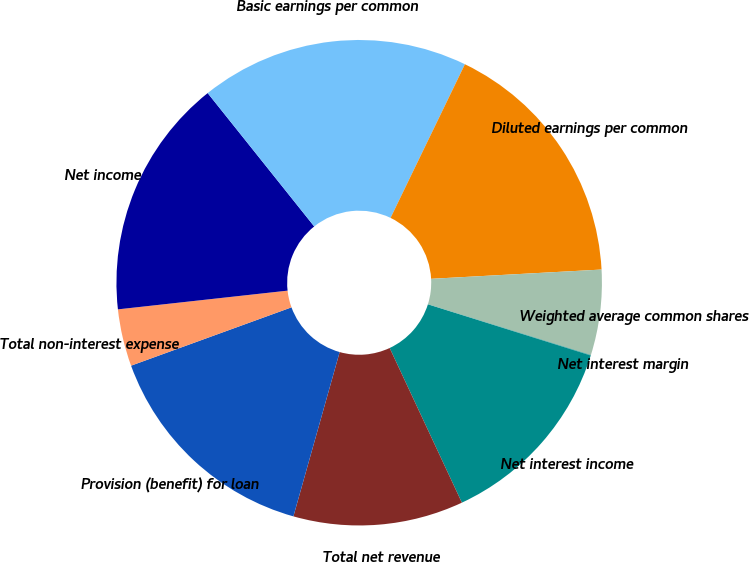<chart> <loc_0><loc_0><loc_500><loc_500><pie_chart><fcel>Net interest income<fcel>Total net revenue<fcel>Provision (benefit) for loan<fcel>Total non-interest expense<fcel>Net income<fcel>Basic earnings per common<fcel>Diluted earnings per common<fcel>Weighted average common shares<fcel>Net interest margin<nl><fcel>13.2%<fcel>11.32%<fcel>15.08%<fcel>3.8%<fcel>16.02%<fcel>17.9%<fcel>16.96%<fcel>5.68%<fcel>0.03%<nl></chart> 